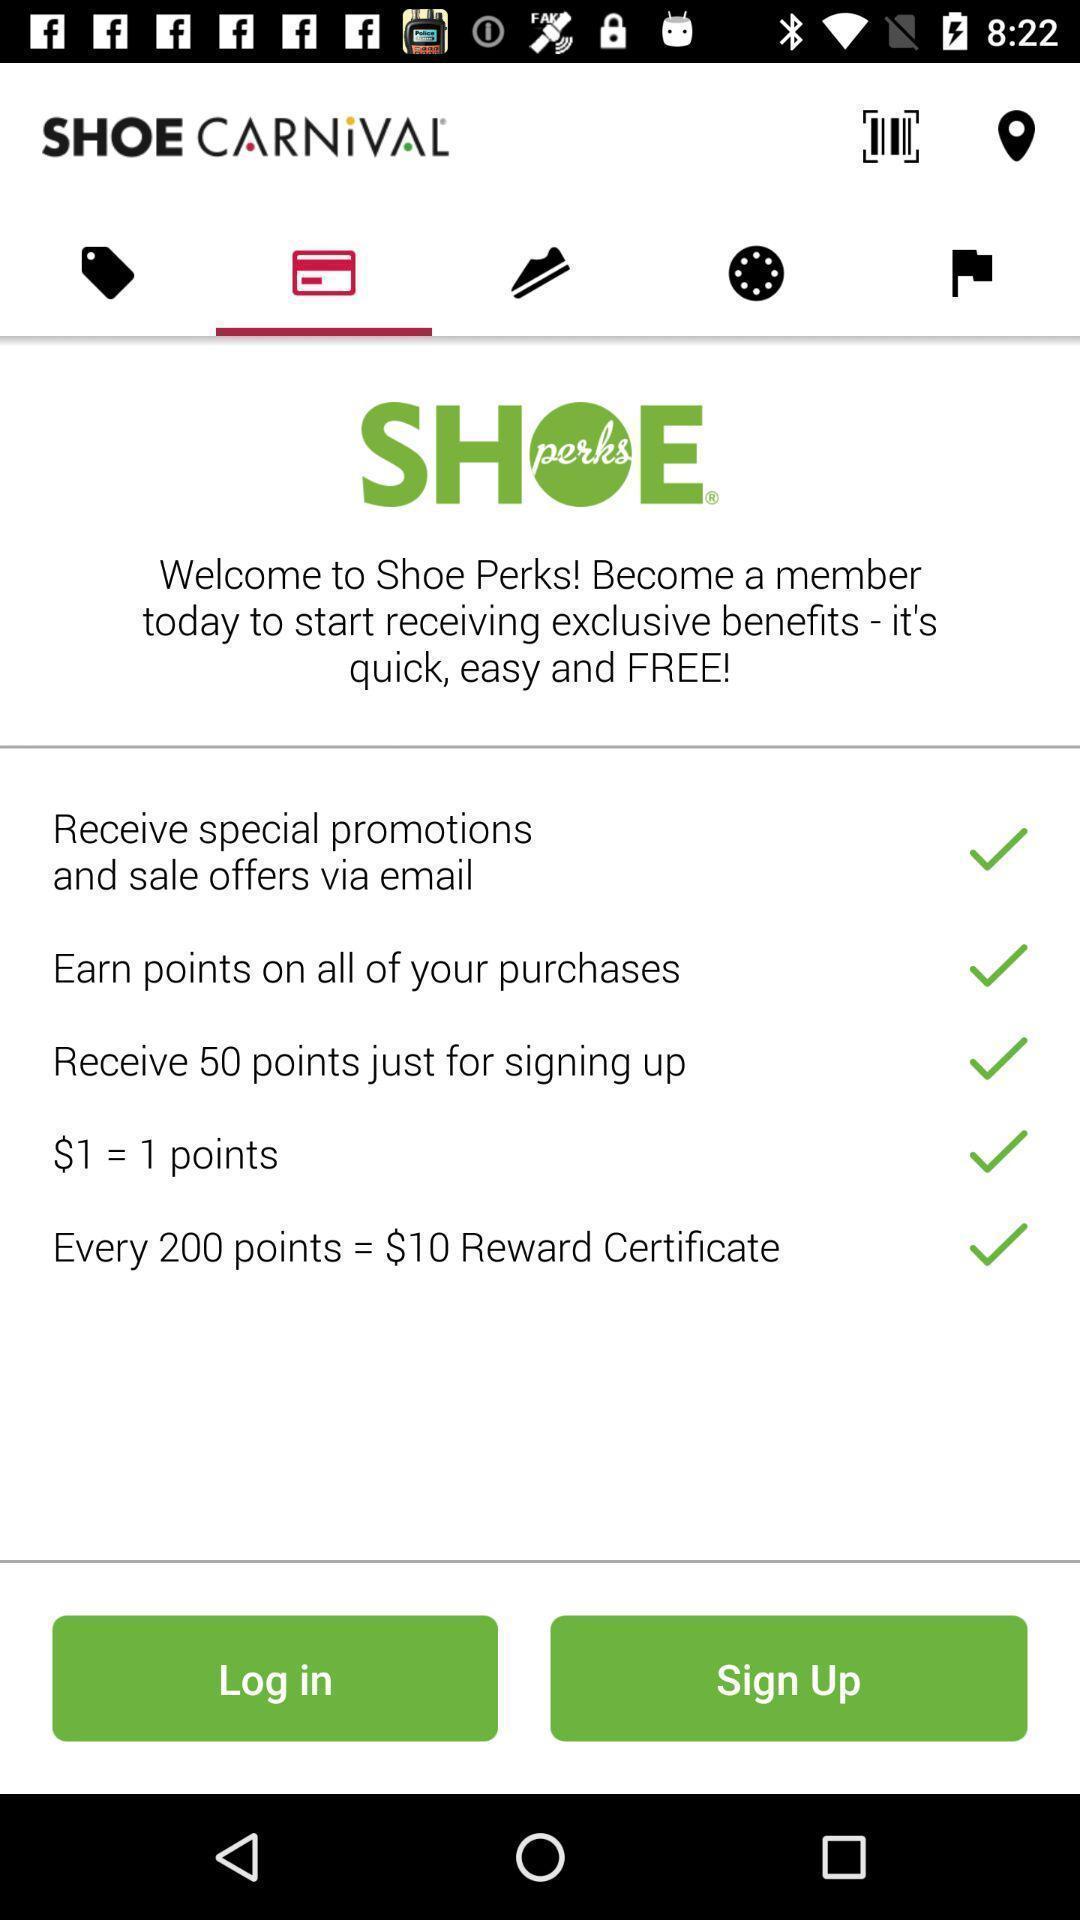Tell me what you see in this picture. Welcome page. 